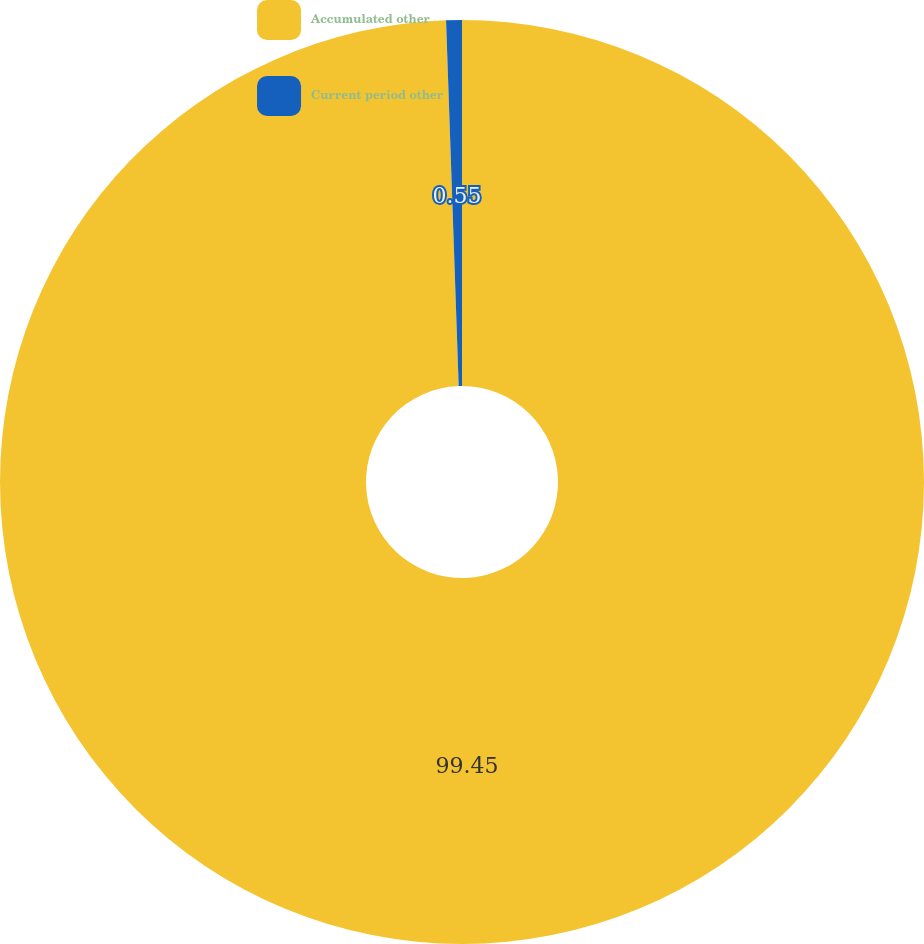<chart> <loc_0><loc_0><loc_500><loc_500><pie_chart><fcel>Accumulated other<fcel>Current period other<nl><fcel>99.45%<fcel>0.55%<nl></chart> 